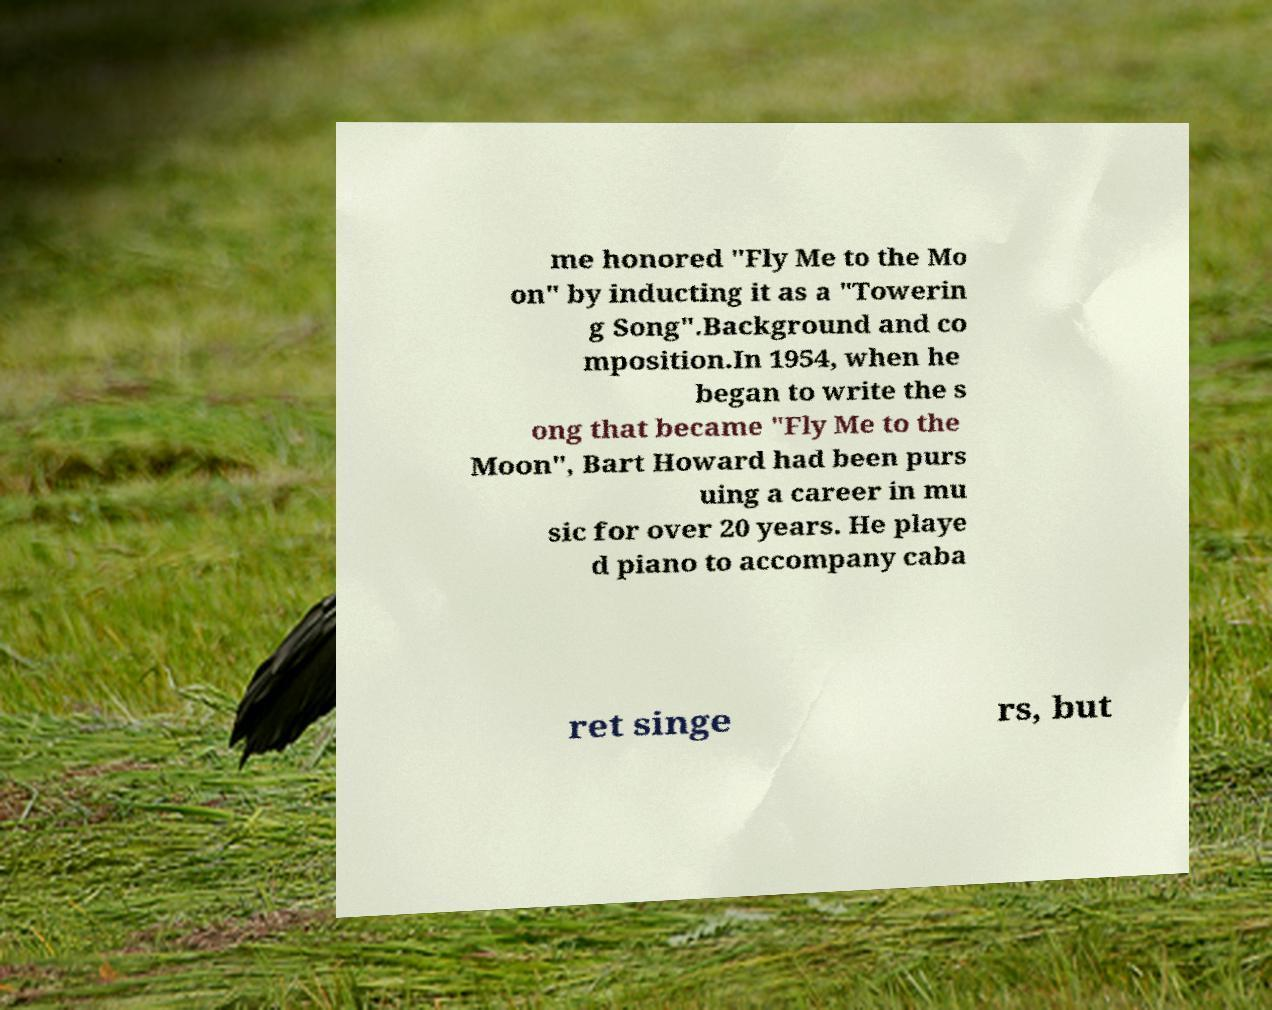Could you extract and type out the text from this image? me honored "Fly Me to the Mo on" by inducting it as a "Towerin g Song".Background and co mposition.In 1954, when he began to write the s ong that became "Fly Me to the Moon", Bart Howard had been purs uing a career in mu sic for over 20 years. He playe d piano to accompany caba ret singe rs, but 